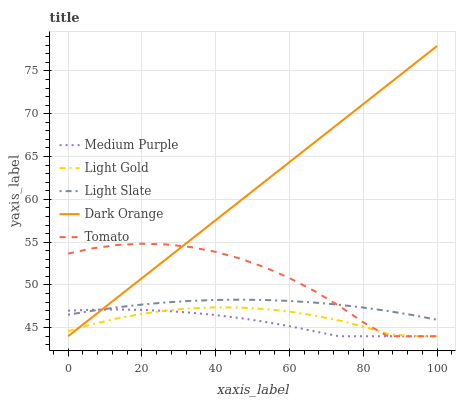Does Medium Purple have the minimum area under the curve?
Answer yes or no. Yes. Does Dark Orange have the maximum area under the curve?
Answer yes or no. Yes. Does Light Slate have the minimum area under the curve?
Answer yes or no. No. Does Light Slate have the maximum area under the curve?
Answer yes or no. No. Is Dark Orange the smoothest?
Answer yes or no. Yes. Is Tomato the roughest?
Answer yes or no. Yes. Is Light Slate the smoothest?
Answer yes or no. No. Is Light Slate the roughest?
Answer yes or no. No. Does Medium Purple have the lowest value?
Answer yes or no. Yes. Does Light Slate have the lowest value?
Answer yes or no. No. Does Dark Orange have the highest value?
Answer yes or no. Yes. Does Light Slate have the highest value?
Answer yes or no. No. Is Light Gold less than Light Slate?
Answer yes or no. Yes. Is Light Slate greater than Light Gold?
Answer yes or no. Yes. Does Dark Orange intersect Light Slate?
Answer yes or no. Yes. Is Dark Orange less than Light Slate?
Answer yes or no. No. Is Dark Orange greater than Light Slate?
Answer yes or no. No. Does Light Gold intersect Light Slate?
Answer yes or no. No. 